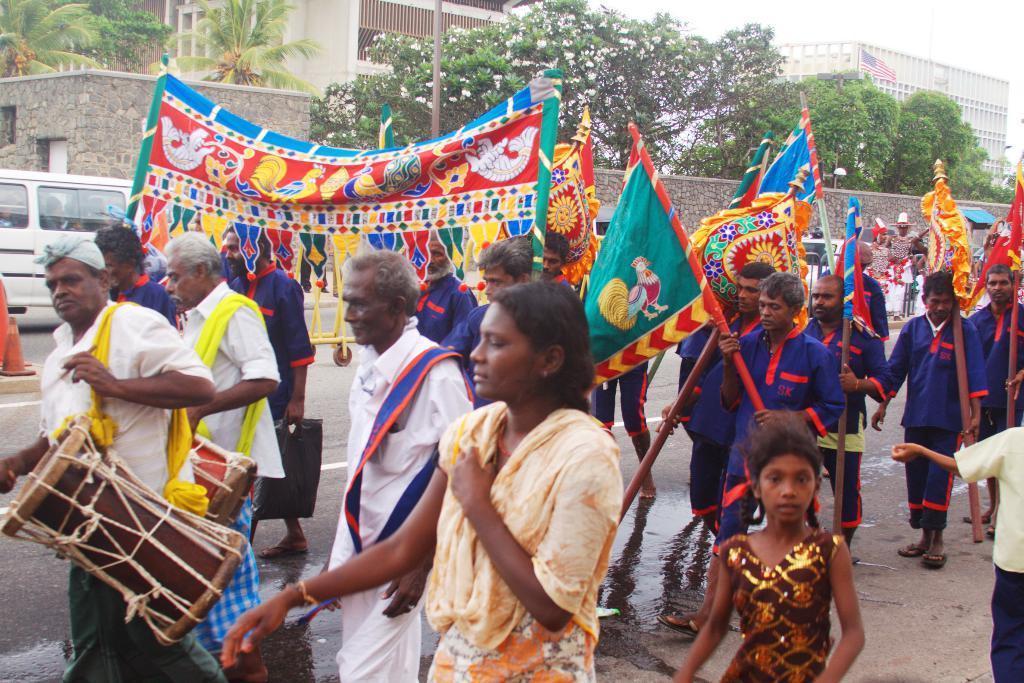Could you give a brief overview of what you see in this image? In this picture a group of people walking on the road and in the background of plants buildings and sky is clear. 